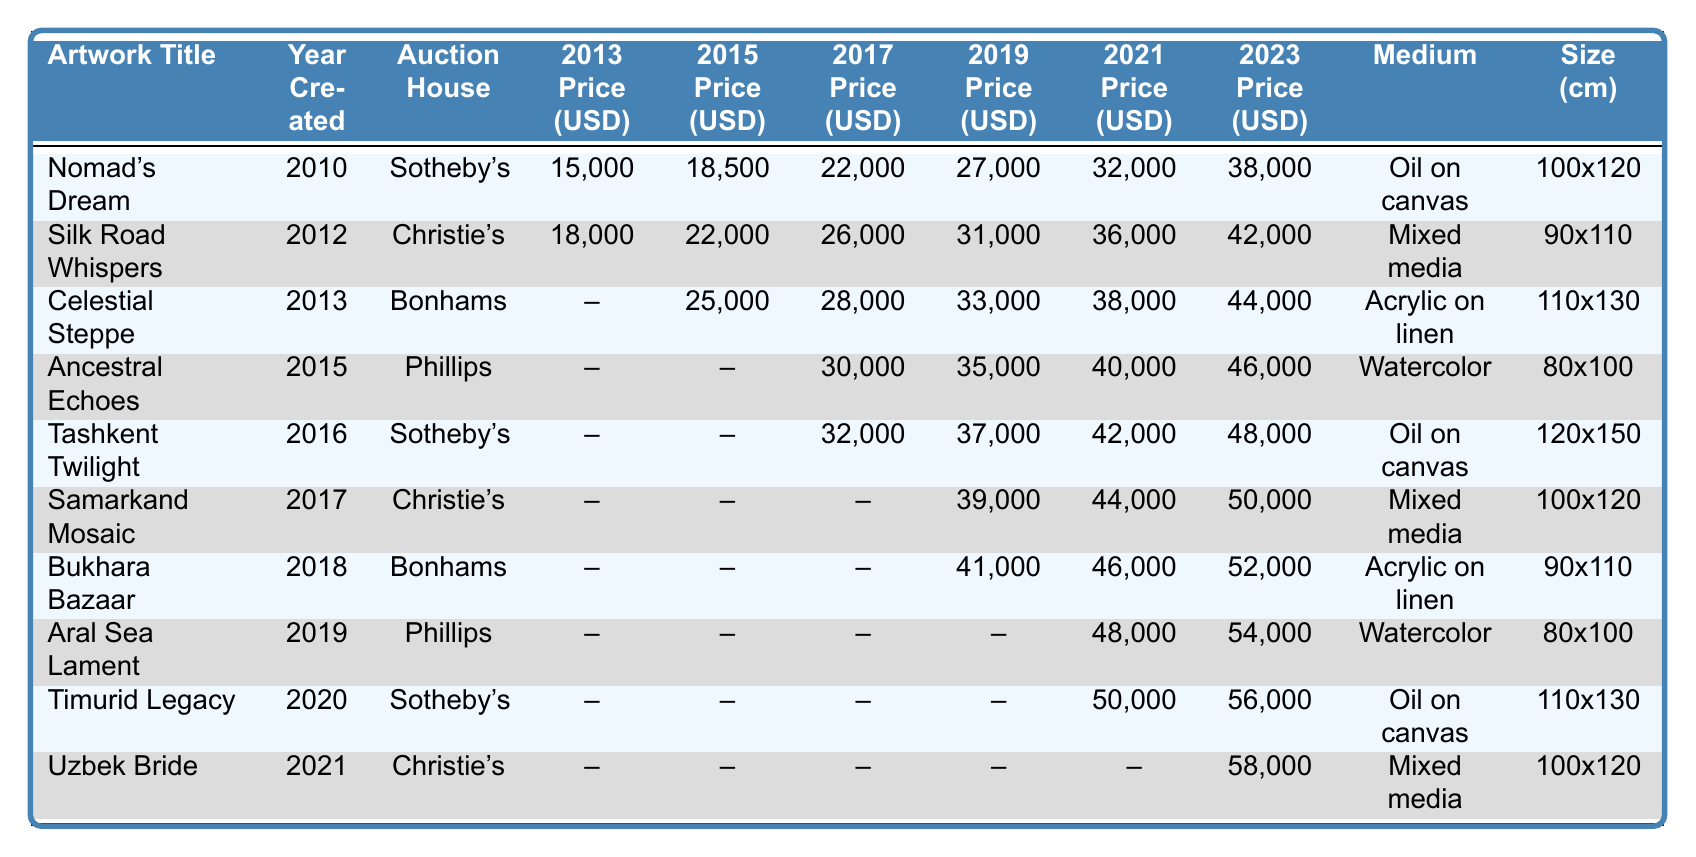What is the highest price achieved for "Nomad's Dream"? Referring to the table, the highest price for "Nomad's Dream" is listed in the 2023 column, which shows a price of 38,000 USD.
Answer: 38,000 USD Which auction house sold "Aral Sea Lament"? The table indicates that "Aral Sea Lament" was sold at Phillips.
Answer: Phillips What is the average price of "Celestial Steppe" across all years listed? The prices for "Celestial Steppe" are: 25,000 (2015), 28,000 (2017), 33,000 (2019), 38,000 (2021), and 44,000 (2023). The average is calculated as (25,000 + 28,000 + 33,000 + 38,000 + 44,000) / 5 = 33,600.
Answer: 33,600 USD Did "Uzbek Bride" have a price listed for 2019? According to the table, there is no price listed for "Uzbek Bride" in the 2019 column. This means the statement is true.
Answer: No Which artwork had the lowest auction price in 2013? The prices for 2013 are: 15,000 for "Nomad's Dream" and 18,000 for "Silk Road Whispers". Since "Nomad's Dream" has the lowest value among them, it is the answer.
Answer: Nomad's Dream What was the percentage increase in price for "Timurid Legacy" from 2021 to 2023? The price in 2021 for "Timurid Legacy" is 50,000, and in 2023 it is 56,000. The increase is calculated as (56,000 - 50,000) / 50,000 * 100% = 12%.
Answer: 12% How many artworks were sold at Sotheby's? By counting the entries under Sotheby's in the auction house column, we find there are 4 artworks sold at Sotheby's: "Nomad's Dream," "Tashkent Twilight," "Timurid Legacy," and "Uzbek Bride."
Answer: 4 What is the medium of the artwork with the highest price in 2023? Referring to the 2023 prices, "Uzbek Bride" had the highest price at 58,000 USD. The medium for "Uzbek Bride" is mixed media.
Answer: Mixed media Is there a consistent increase in the auction price for "Samarkand Mosaic" from 2017 to 2023? The prices for "Samarkand Mosaic" are: 44,000 (2021) and 50,000 (2023). Since the price increased from 44,000 to 50,000, this confirms a consistent increase in the price.
Answer: Yes What is the ratio of the highest price in 2019 to the lowest price in 2019? The highest price in 2019 is 41,000 for "Bukhara Bazaar" and the lowest is 0 (no price listed for "Aral Sea Lament"). However, since we cannot divide by zero, the ratio is undefined.
Answer: Undefined 